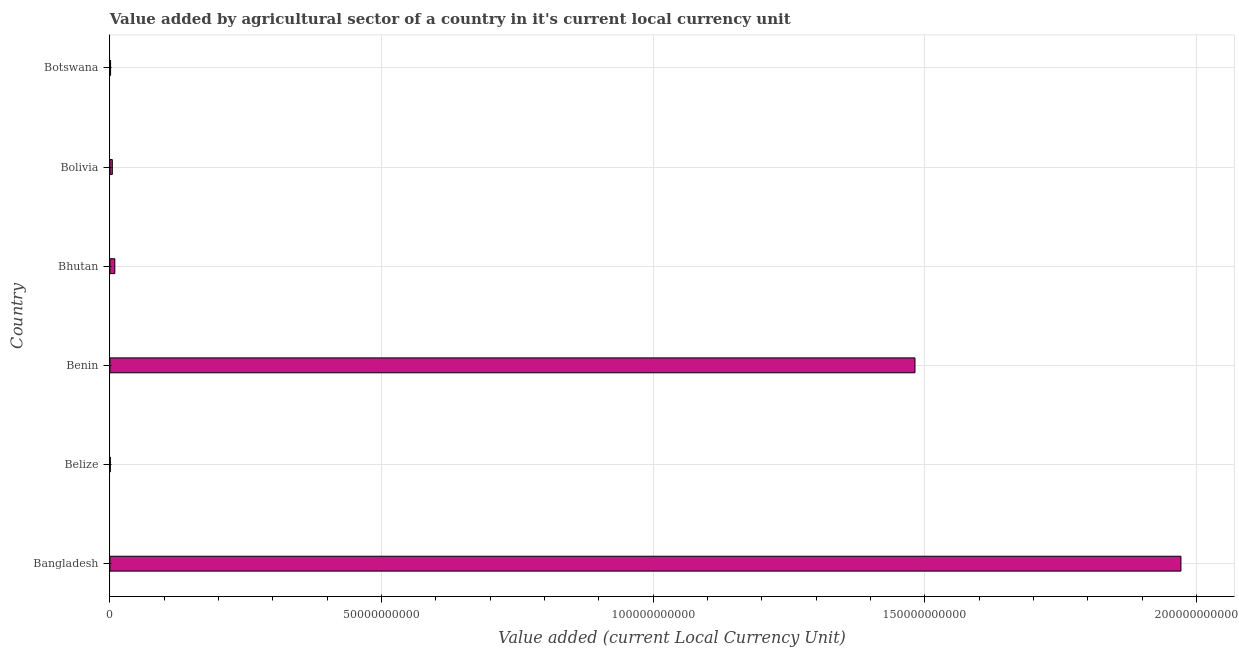Does the graph contain any zero values?
Your answer should be very brief. No. What is the title of the graph?
Offer a very short reply. Value added by agricultural sector of a country in it's current local currency unit. What is the label or title of the X-axis?
Provide a succinct answer. Value added (current Local Currency Unit). What is the label or title of the Y-axis?
Offer a very short reply. Country. What is the value added by agriculture sector in Bangladesh?
Ensure brevity in your answer.  1.97e+11. Across all countries, what is the maximum value added by agriculture sector?
Make the answer very short. 1.97e+11. Across all countries, what is the minimum value added by agriculture sector?
Keep it short and to the point. 7.46e+07. In which country was the value added by agriculture sector maximum?
Keep it short and to the point. Bangladesh. In which country was the value added by agriculture sector minimum?
Provide a succinct answer. Belize. What is the sum of the value added by agriculture sector?
Your answer should be very brief. 3.47e+11. What is the difference between the value added by agriculture sector in Bangladesh and Botswana?
Provide a short and direct response. 1.97e+11. What is the average value added by agriculture sector per country?
Your response must be concise. 5.78e+1. What is the median value added by agriculture sector?
Your answer should be very brief. 6.79e+08. What is the ratio of the value added by agriculture sector in Benin to that in Bolivia?
Your answer should be very brief. 329.38. Is the value added by agriculture sector in Belize less than that in Botswana?
Provide a succinct answer. Yes. What is the difference between the highest and the second highest value added by agriculture sector?
Provide a succinct answer. 4.90e+1. Is the sum of the value added by agriculture sector in Benin and Bhutan greater than the maximum value added by agriculture sector across all countries?
Your response must be concise. No. What is the difference between the highest and the lowest value added by agriculture sector?
Offer a terse response. 1.97e+11. In how many countries, is the value added by agriculture sector greater than the average value added by agriculture sector taken over all countries?
Offer a very short reply. 2. How many countries are there in the graph?
Your response must be concise. 6. What is the difference between two consecutive major ticks on the X-axis?
Keep it short and to the point. 5.00e+1. Are the values on the major ticks of X-axis written in scientific E-notation?
Offer a terse response. No. What is the Value added (current Local Currency Unit) of Bangladesh?
Give a very brief answer. 1.97e+11. What is the Value added (current Local Currency Unit) of Belize?
Offer a terse response. 7.46e+07. What is the Value added (current Local Currency Unit) of Benin?
Make the answer very short. 1.48e+11. What is the Value added (current Local Currency Unit) in Bhutan?
Your response must be concise. 9.08e+08. What is the Value added (current Local Currency Unit) in Bolivia?
Ensure brevity in your answer.  4.50e+08. What is the Value added (current Local Currency Unit) of Botswana?
Ensure brevity in your answer.  1.26e+08. What is the difference between the Value added (current Local Currency Unit) in Bangladesh and Belize?
Provide a short and direct response. 1.97e+11. What is the difference between the Value added (current Local Currency Unit) in Bangladesh and Benin?
Make the answer very short. 4.90e+1. What is the difference between the Value added (current Local Currency Unit) in Bangladesh and Bhutan?
Provide a succinct answer. 1.96e+11. What is the difference between the Value added (current Local Currency Unit) in Bangladesh and Bolivia?
Offer a terse response. 1.97e+11. What is the difference between the Value added (current Local Currency Unit) in Bangladesh and Botswana?
Keep it short and to the point. 1.97e+11. What is the difference between the Value added (current Local Currency Unit) in Belize and Benin?
Offer a terse response. -1.48e+11. What is the difference between the Value added (current Local Currency Unit) in Belize and Bhutan?
Your answer should be compact. -8.34e+08. What is the difference between the Value added (current Local Currency Unit) in Belize and Bolivia?
Give a very brief answer. -3.75e+08. What is the difference between the Value added (current Local Currency Unit) in Belize and Botswana?
Make the answer very short. -5.10e+07. What is the difference between the Value added (current Local Currency Unit) in Benin and Bhutan?
Keep it short and to the point. 1.47e+11. What is the difference between the Value added (current Local Currency Unit) in Benin and Bolivia?
Keep it short and to the point. 1.48e+11. What is the difference between the Value added (current Local Currency Unit) in Benin and Botswana?
Give a very brief answer. 1.48e+11. What is the difference between the Value added (current Local Currency Unit) in Bhutan and Bolivia?
Offer a very short reply. 4.58e+08. What is the difference between the Value added (current Local Currency Unit) in Bhutan and Botswana?
Offer a very short reply. 7.83e+08. What is the difference between the Value added (current Local Currency Unit) in Bolivia and Botswana?
Give a very brief answer. 3.24e+08. What is the ratio of the Value added (current Local Currency Unit) in Bangladesh to that in Belize?
Ensure brevity in your answer.  2643.55. What is the ratio of the Value added (current Local Currency Unit) in Bangladesh to that in Benin?
Your response must be concise. 1.33. What is the ratio of the Value added (current Local Currency Unit) in Bangladesh to that in Bhutan?
Provide a short and direct response. 217.1. What is the ratio of the Value added (current Local Currency Unit) in Bangladesh to that in Bolivia?
Your response must be concise. 438.18. What is the ratio of the Value added (current Local Currency Unit) in Bangladesh to that in Botswana?
Provide a short and direct response. 1569.71. What is the ratio of the Value added (current Local Currency Unit) in Belize to that in Benin?
Give a very brief answer. 0. What is the ratio of the Value added (current Local Currency Unit) in Belize to that in Bhutan?
Your response must be concise. 0.08. What is the ratio of the Value added (current Local Currency Unit) in Belize to that in Bolivia?
Offer a very short reply. 0.17. What is the ratio of the Value added (current Local Currency Unit) in Belize to that in Botswana?
Your answer should be compact. 0.59. What is the ratio of the Value added (current Local Currency Unit) in Benin to that in Bhutan?
Make the answer very short. 163.19. What is the ratio of the Value added (current Local Currency Unit) in Benin to that in Bolivia?
Keep it short and to the point. 329.38. What is the ratio of the Value added (current Local Currency Unit) in Benin to that in Botswana?
Keep it short and to the point. 1179.94. What is the ratio of the Value added (current Local Currency Unit) in Bhutan to that in Bolivia?
Ensure brevity in your answer.  2.02. What is the ratio of the Value added (current Local Currency Unit) in Bhutan to that in Botswana?
Offer a very short reply. 7.23. What is the ratio of the Value added (current Local Currency Unit) in Bolivia to that in Botswana?
Give a very brief answer. 3.58. 